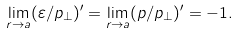Convert formula to latex. <formula><loc_0><loc_0><loc_500><loc_500>\lim _ { r \to a } ( \varepsilon / p _ { \perp } ) ^ { \prime } = \lim _ { r \to a } ( p / p _ { \perp } ) ^ { \prime } = - 1 .</formula> 